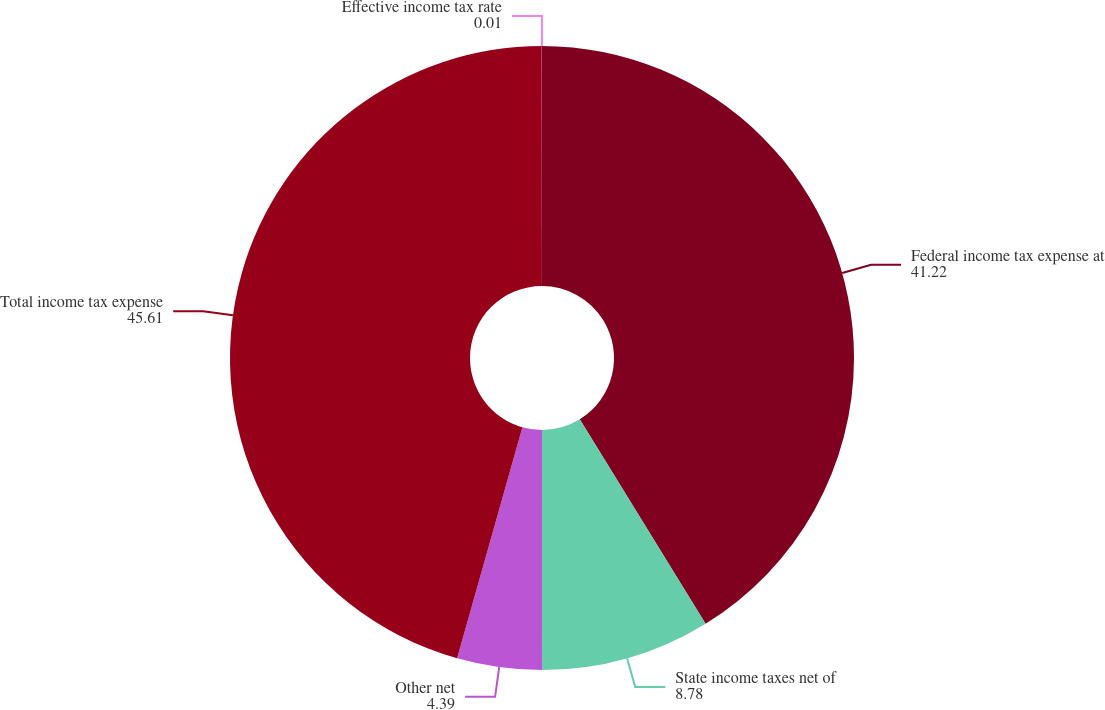<chart> <loc_0><loc_0><loc_500><loc_500><pie_chart><fcel>Federal income tax expense at<fcel>State income taxes net of<fcel>Other net<fcel>Total income tax expense<fcel>Effective income tax rate<nl><fcel>41.22%<fcel>8.78%<fcel>4.39%<fcel>45.61%<fcel>0.01%<nl></chart> 